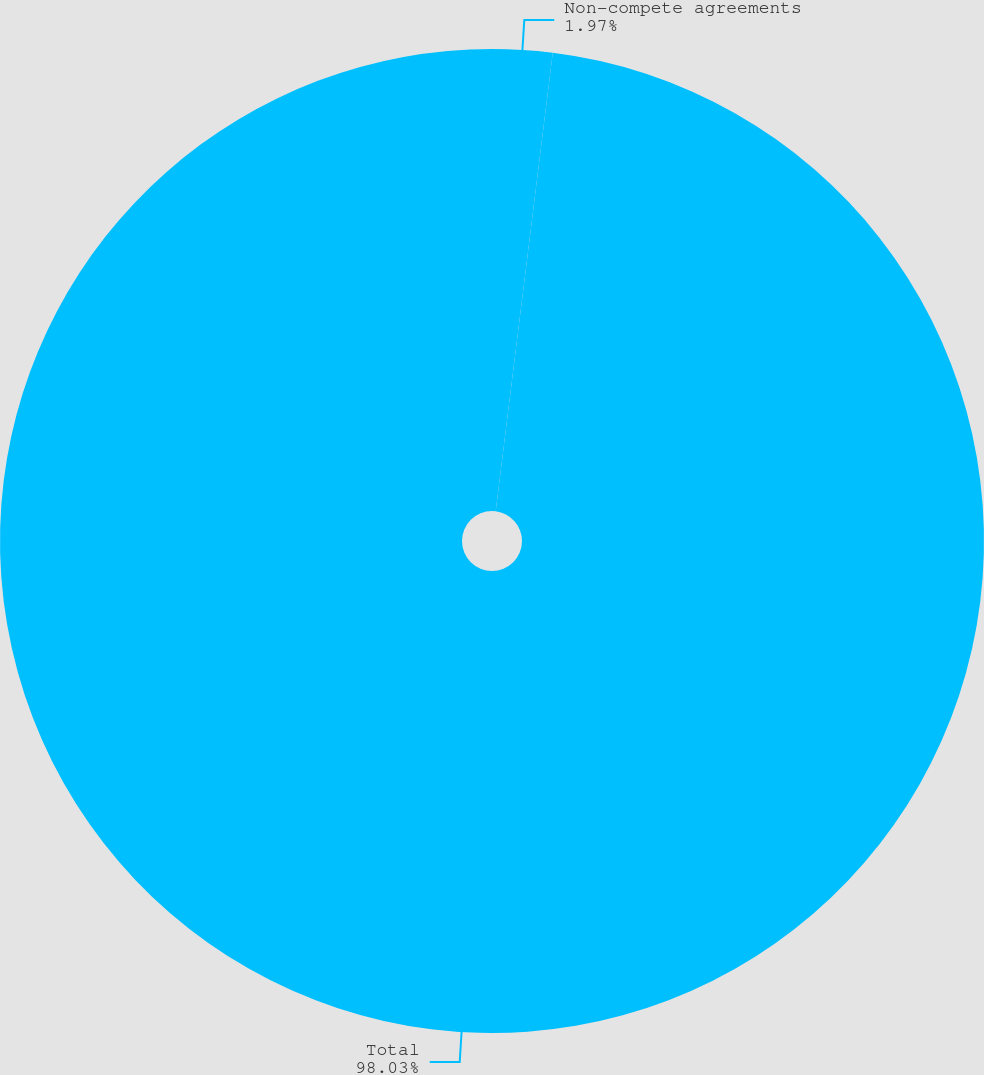Convert chart. <chart><loc_0><loc_0><loc_500><loc_500><pie_chart><fcel>Non-compete agreements<fcel>Total<nl><fcel>1.97%<fcel>98.03%<nl></chart> 